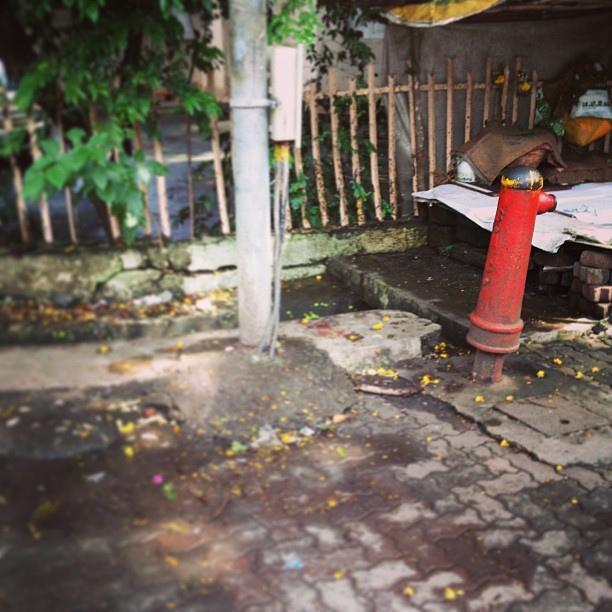How many of the bears legs are bent?
Give a very brief answer. 0. 